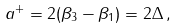<formula> <loc_0><loc_0><loc_500><loc_500>a ^ { + } = 2 ( \beta _ { 3 } - \beta _ { 1 } ) = 2 \Delta \, ,</formula> 